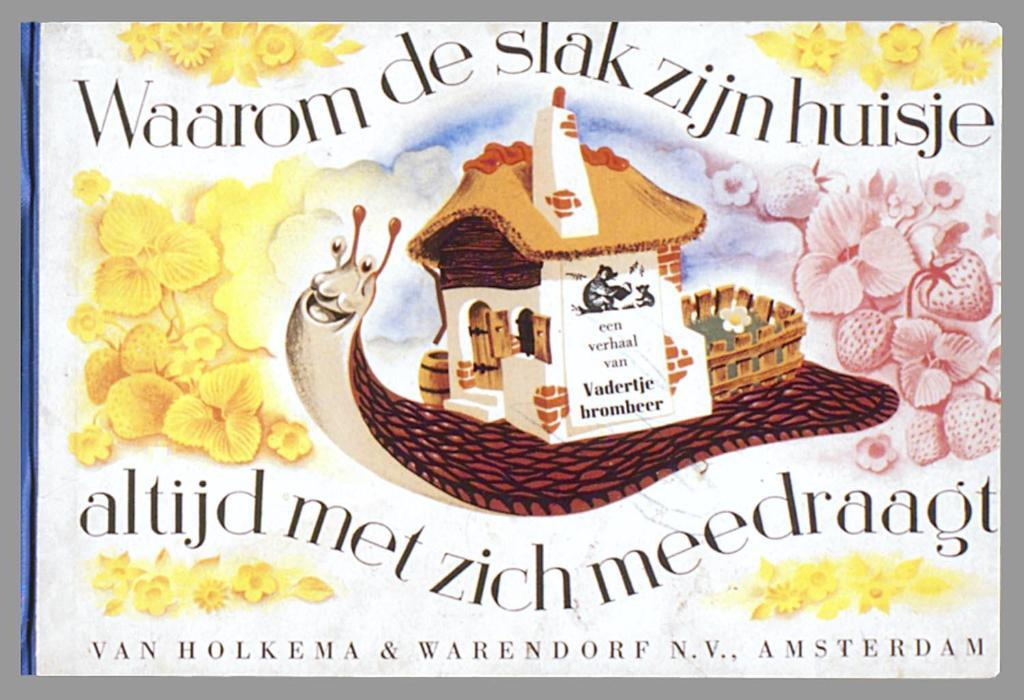What is the main subject of the image? The main subject of the image is a poster. What elements are present on the poster? The poster contains flowers, text, a house, and a mammal. What type of frame is the image in? The image appears to be in a photo frame. What type of tin can be seen in the image? There is no tin present in the image. How many men are visible in the image? There are no men visible in the image; it features a poster with various elements. 